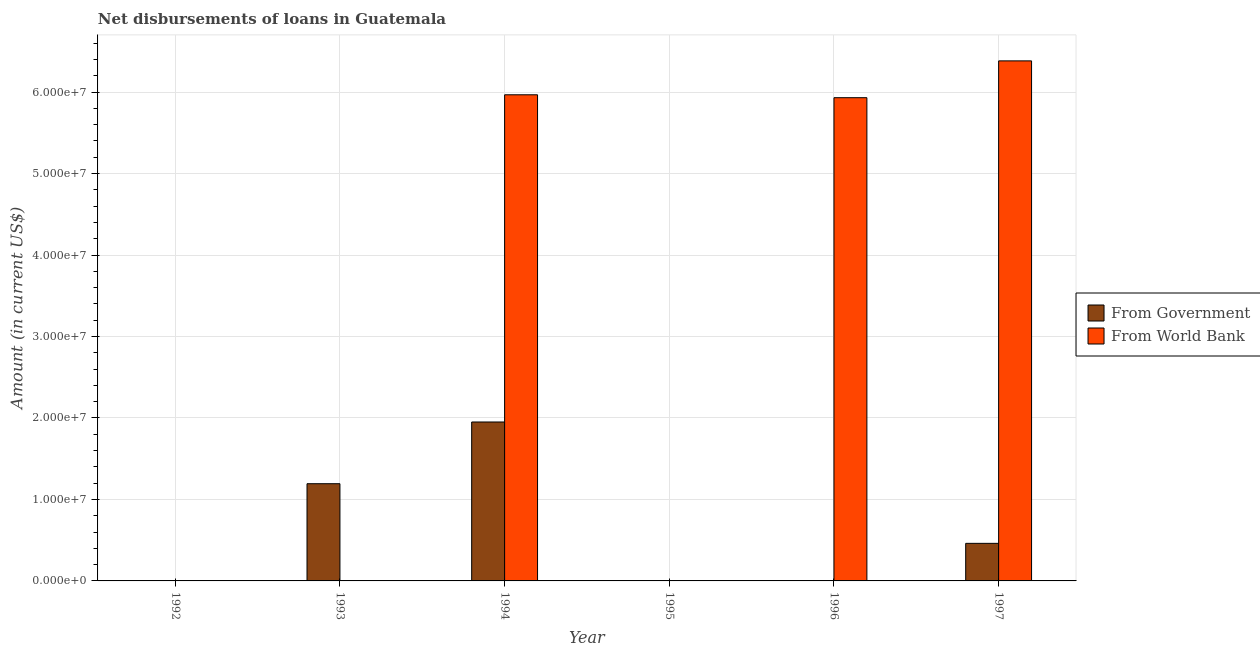Are the number of bars per tick equal to the number of legend labels?
Offer a very short reply. No. What is the net disbursements of loan from world bank in 1994?
Your answer should be compact. 5.97e+07. Across all years, what is the maximum net disbursements of loan from government?
Offer a very short reply. 1.95e+07. Across all years, what is the minimum net disbursements of loan from government?
Make the answer very short. 0. What is the total net disbursements of loan from government in the graph?
Your response must be concise. 3.60e+07. What is the difference between the net disbursements of loan from world bank in 1994 and that in 1997?
Make the answer very short. -4.16e+06. What is the difference between the net disbursements of loan from world bank in 1994 and the net disbursements of loan from government in 1997?
Provide a short and direct response. -4.16e+06. What is the average net disbursements of loan from world bank per year?
Your answer should be compact. 3.05e+07. In the year 1997, what is the difference between the net disbursements of loan from government and net disbursements of loan from world bank?
Offer a very short reply. 0. What is the ratio of the net disbursements of loan from world bank in 1994 to that in 1997?
Keep it short and to the point. 0.93. Is the difference between the net disbursements of loan from world bank in 1994 and 1996 greater than the difference between the net disbursements of loan from government in 1994 and 1996?
Your answer should be very brief. No. What is the difference between the highest and the second highest net disbursements of loan from government?
Offer a very short reply. 7.58e+06. What is the difference between the highest and the lowest net disbursements of loan from government?
Make the answer very short. 1.95e+07. How many bars are there?
Offer a very short reply. 6. What is the difference between two consecutive major ticks on the Y-axis?
Ensure brevity in your answer.  1.00e+07. How many legend labels are there?
Keep it short and to the point. 2. What is the title of the graph?
Your answer should be compact. Net disbursements of loans in Guatemala. Does "Exports of goods" appear as one of the legend labels in the graph?
Keep it short and to the point. No. What is the label or title of the X-axis?
Offer a very short reply. Year. What is the Amount (in current US$) of From Government in 1993?
Provide a short and direct response. 1.19e+07. What is the Amount (in current US$) of From World Bank in 1993?
Provide a succinct answer. 0. What is the Amount (in current US$) of From Government in 1994?
Your response must be concise. 1.95e+07. What is the Amount (in current US$) in From World Bank in 1994?
Your answer should be very brief. 5.97e+07. What is the Amount (in current US$) in From Government in 1995?
Provide a succinct answer. 0. What is the Amount (in current US$) in From Government in 1996?
Give a very brief answer. 0. What is the Amount (in current US$) of From World Bank in 1996?
Offer a very short reply. 5.93e+07. What is the Amount (in current US$) in From Government in 1997?
Make the answer very short. 4.61e+06. What is the Amount (in current US$) in From World Bank in 1997?
Make the answer very short. 6.38e+07. Across all years, what is the maximum Amount (in current US$) of From Government?
Offer a very short reply. 1.95e+07. Across all years, what is the maximum Amount (in current US$) of From World Bank?
Keep it short and to the point. 6.38e+07. Across all years, what is the minimum Amount (in current US$) of From Government?
Your answer should be very brief. 0. What is the total Amount (in current US$) of From Government in the graph?
Your response must be concise. 3.60e+07. What is the total Amount (in current US$) of From World Bank in the graph?
Provide a short and direct response. 1.83e+08. What is the difference between the Amount (in current US$) in From Government in 1993 and that in 1994?
Your answer should be compact. -7.58e+06. What is the difference between the Amount (in current US$) of From Government in 1993 and that in 1997?
Make the answer very short. 7.32e+06. What is the difference between the Amount (in current US$) of From World Bank in 1994 and that in 1996?
Give a very brief answer. 3.56e+05. What is the difference between the Amount (in current US$) of From Government in 1994 and that in 1997?
Keep it short and to the point. 1.49e+07. What is the difference between the Amount (in current US$) of From World Bank in 1994 and that in 1997?
Offer a very short reply. -4.16e+06. What is the difference between the Amount (in current US$) of From World Bank in 1996 and that in 1997?
Provide a short and direct response. -4.52e+06. What is the difference between the Amount (in current US$) of From Government in 1993 and the Amount (in current US$) of From World Bank in 1994?
Ensure brevity in your answer.  -4.77e+07. What is the difference between the Amount (in current US$) in From Government in 1993 and the Amount (in current US$) in From World Bank in 1996?
Offer a very short reply. -4.74e+07. What is the difference between the Amount (in current US$) of From Government in 1993 and the Amount (in current US$) of From World Bank in 1997?
Ensure brevity in your answer.  -5.19e+07. What is the difference between the Amount (in current US$) in From Government in 1994 and the Amount (in current US$) in From World Bank in 1996?
Offer a terse response. -3.98e+07. What is the difference between the Amount (in current US$) in From Government in 1994 and the Amount (in current US$) in From World Bank in 1997?
Your response must be concise. -4.43e+07. What is the average Amount (in current US$) in From Government per year?
Ensure brevity in your answer.  6.01e+06. What is the average Amount (in current US$) of From World Bank per year?
Provide a succinct answer. 3.05e+07. In the year 1994, what is the difference between the Amount (in current US$) of From Government and Amount (in current US$) of From World Bank?
Make the answer very short. -4.02e+07. In the year 1997, what is the difference between the Amount (in current US$) of From Government and Amount (in current US$) of From World Bank?
Provide a short and direct response. -5.92e+07. What is the ratio of the Amount (in current US$) of From Government in 1993 to that in 1994?
Your response must be concise. 0.61. What is the ratio of the Amount (in current US$) in From Government in 1993 to that in 1997?
Offer a very short reply. 2.59. What is the ratio of the Amount (in current US$) in From World Bank in 1994 to that in 1996?
Your response must be concise. 1.01. What is the ratio of the Amount (in current US$) in From Government in 1994 to that in 1997?
Provide a short and direct response. 4.23. What is the ratio of the Amount (in current US$) in From World Bank in 1994 to that in 1997?
Your response must be concise. 0.93. What is the ratio of the Amount (in current US$) in From World Bank in 1996 to that in 1997?
Your answer should be very brief. 0.93. What is the difference between the highest and the second highest Amount (in current US$) in From Government?
Offer a very short reply. 7.58e+06. What is the difference between the highest and the second highest Amount (in current US$) in From World Bank?
Keep it short and to the point. 4.16e+06. What is the difference between the highest and the lowest Amount (in current US$) in From Government?
Offer a terse response. 1.95e+07. What is the difference between the highest and the lowest Amount (in current US$) of From World Bank?
Give a very brief answer. 6.38e+07. 